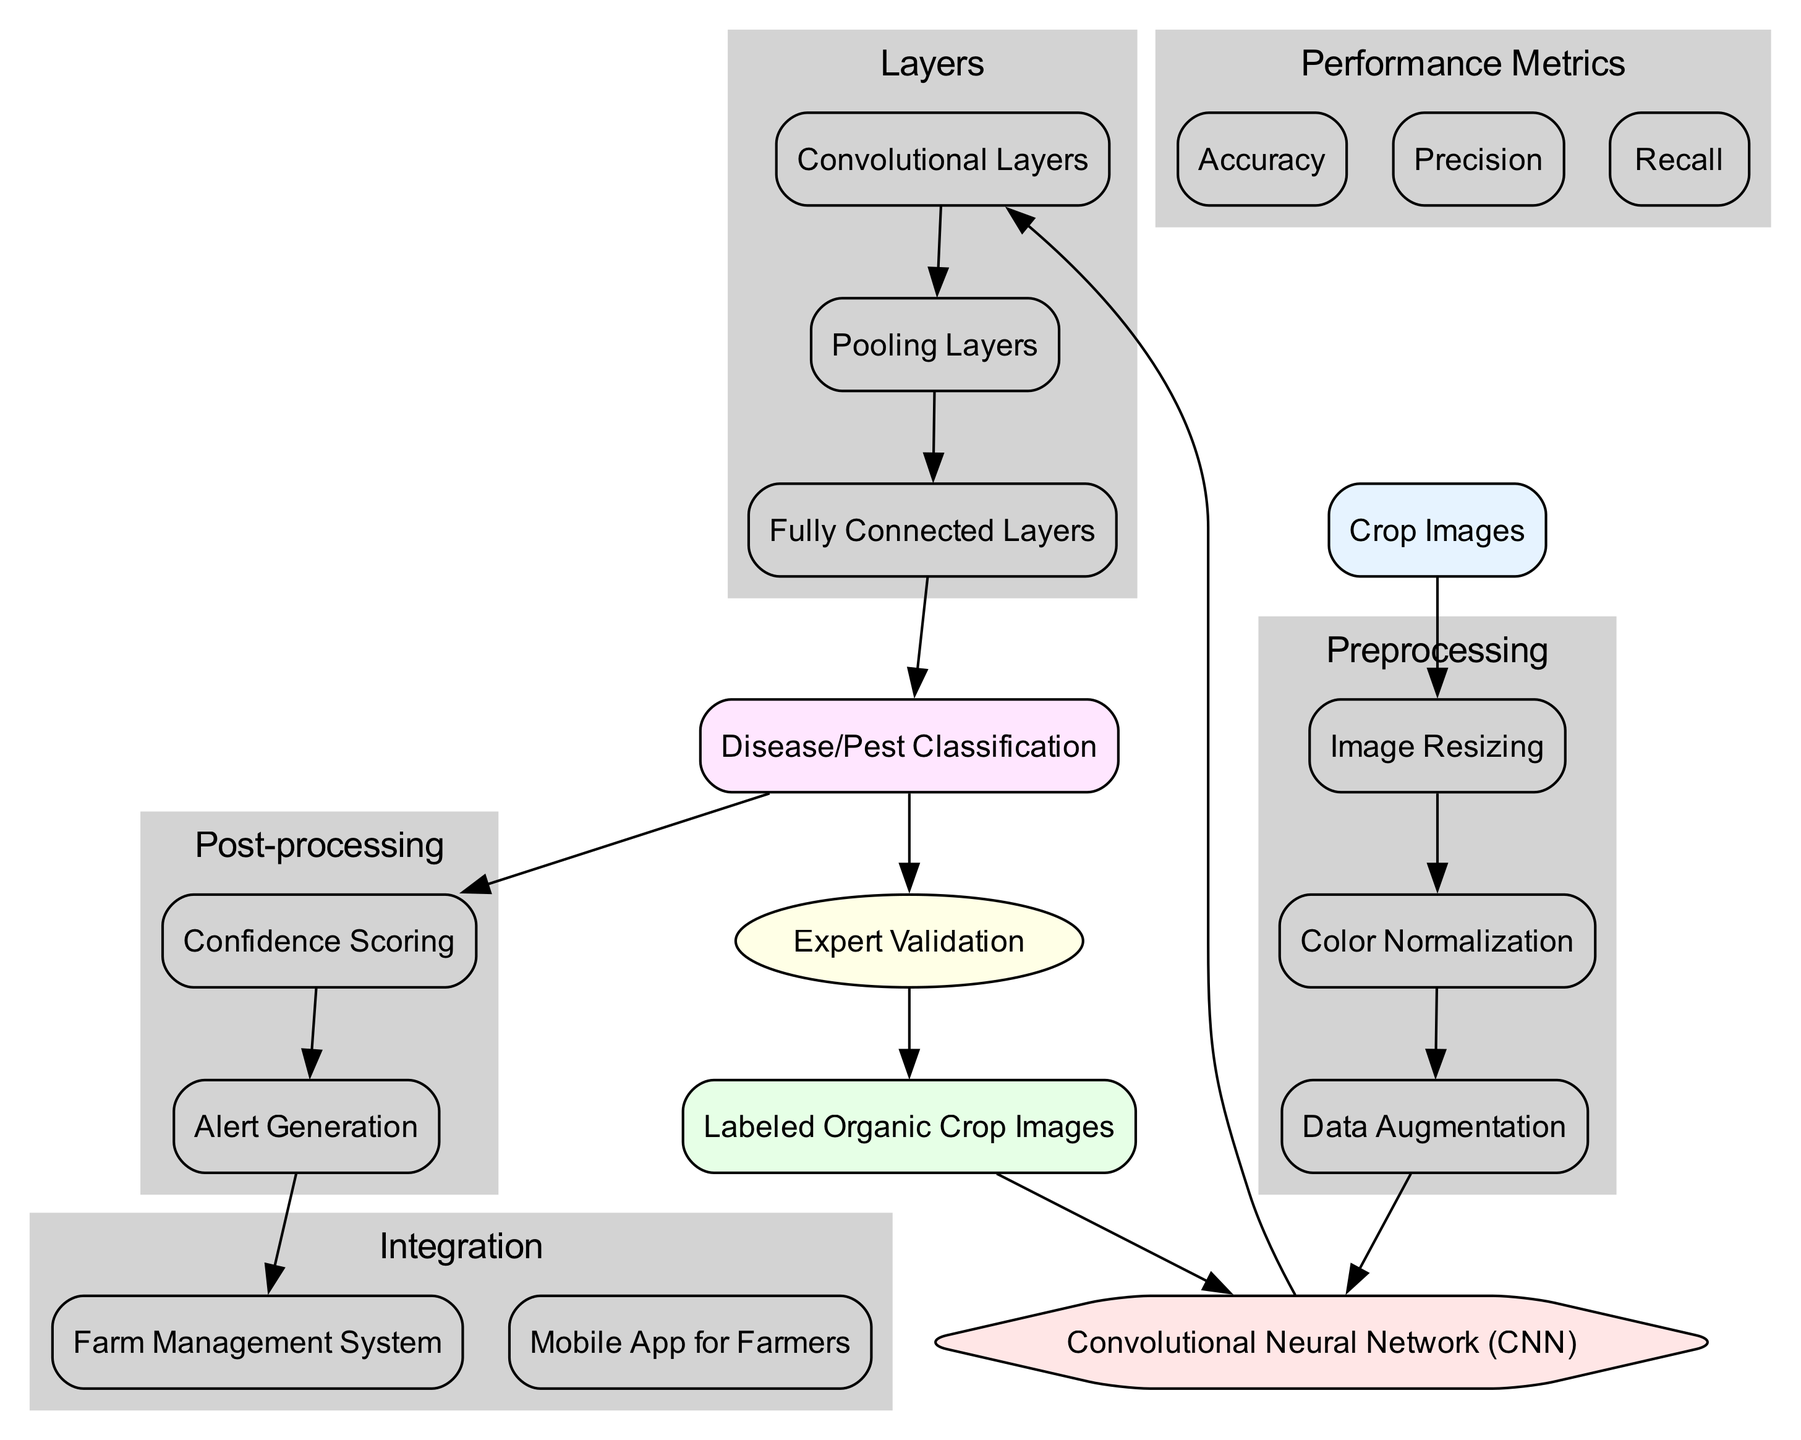What is the input to the diagram? The diagram starts with the node labeled "Crop Images," which represents the input data for the deep learning algorithm.
Answer: Crop Images What type of model is being used? The diagram includes a node indicating "Convolutional Neural Network (CNN)" as the model type utilized for detecting plant diseases and pests.
Answer: Convolutional Neural Network How many preprocessing steps are there? The diagram shows three labeled nodes under the preprocessing section, indicating that there are three distinct steps involved.
Answer: 3 What is the output of the model? The end node of the diagram is labeled "Disease/Pest Classification," which specifies the classification output produced by the model.
Answer: Disease/Pest Classification Which step comes after the training data? The diagram's flow shows that after the "Labeled Organic Crop Images," the next step in the sequence points to the "Convolutional Neural Network (CNN)" model, indicating the order of operations.
Answer: Convolutional Neural Network What is the purpose of the post-processing step? Under the post-processing section, the nodes labeled "Confidence Scoring" and "Alert Generation" provide insight that the post-processing step is intended to evaluate model predictions and generate necessary alerts based on those evaluations.
Answer: Confidence Scoring and Alert Generation Which integration tools are mentioned? The integration section of the diagram lists two tools: "Farm Management System" and "Mobile App for Farmers," indicating how the output will be employed in practical applications.
Answer: Farm Management System, Mobile App for Farmers How is feedback incorporated into the model? The diagram indicates that feedback is derived from "Expert Validation," providing a method for improving the model's accuracy based on expert insights.
Answer: Expert Validation What performance metrics are highlighted? The diagram contains a section on performance metrics, emphasizing three metrics: "Accuracy," "Precision," and "Recall," highlighting the criteria for assessing the model's effectiveness.
Answer: Accuracy, Precision, Recall 